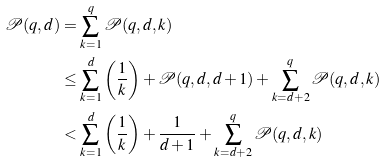Convert formula to latex. <formula><loc_0><loc_0><loc_500><loc_500>\mathcal { P } ( q , d ) & = \sum _ { k = 1 } ^ { q } { \mathcal { P } ( q , d , k ) } \\ & \leq \sum _ { k = 1 } ^ { d } { \left ( \frac { 1 } { k } \right ) } + \mathcal { P } ( q , d , d + 1 ) + \sum _ { k = d + 2 } ^ { q } { \mathcal { P } ( q , d , k ) } \\ & < \sum _ { k = 1 } ^ { d } { \left ( \frac { 1 } { k } \right ) } + \frac { 1 } { d + 1 } + \sum _ { k = d + 2 } ^ { q } { \mathcal { P } ( q , d , k ) }</formula> 